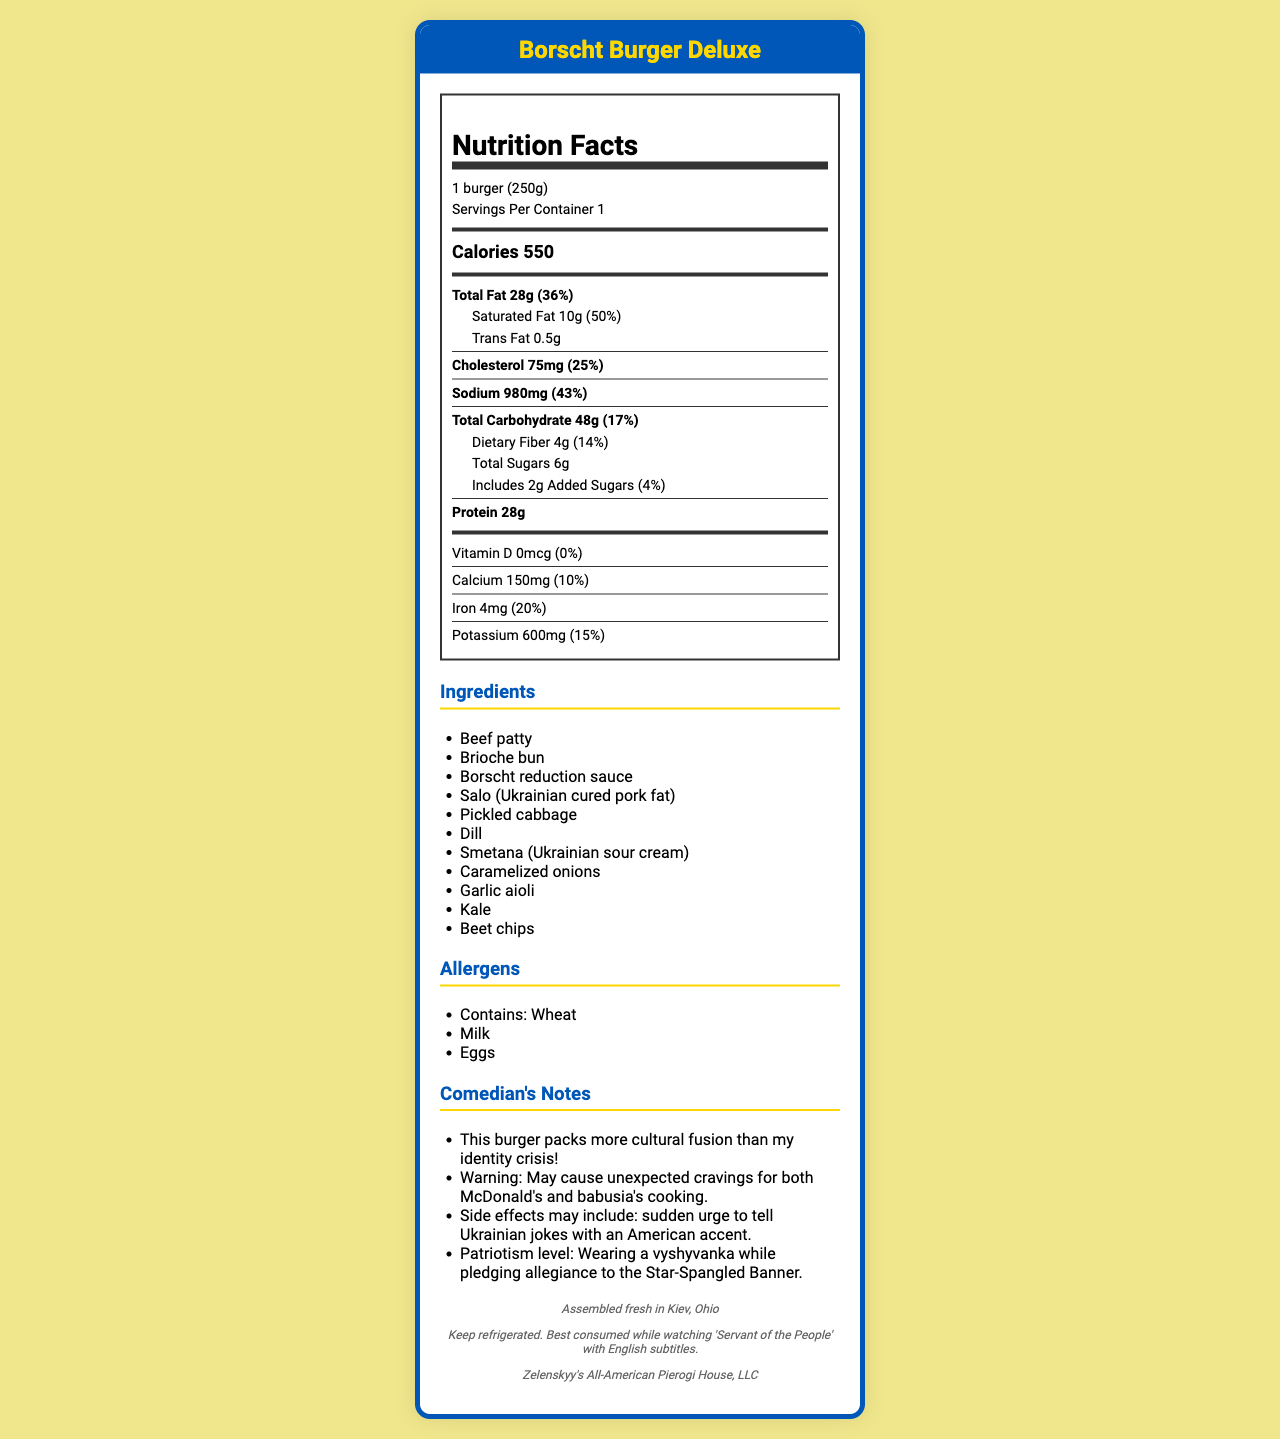what is the serving size of the Borscht Burger Deluxe? The serving size is explicitly mentioned as "1 burger (250g)" in the document.
Answer: 1 burger (250g) how many calories are there in one Borscht Burger Deluxe? The document states that one serving contains 550 calories.
Answer: 550 calories what is the amount of total fat in the Borscht Burger Deluxe? The document lists the total fat content as 28g.
Answer: 28g how much protein does one Borscht Burger Deluxe contain? The document specifies that one serving has 28g of protein.
Answer: 28g which ingredient is used as the sauce in the Borscht Burger Deluxe? Among the ingredients, the Borscht reduction sauce is listed for use in the burger.
Answer: Borscht reduction sauce which of these allergens does the Borscht Burger Deluxe contain? A. Peanuts B. Tree Nuts C. Milk D. Soy The allergens listed include Wheat, Milk, and Eggs. Milk is an option here.
Answer: C what is the preparation method for the Borscht Burger Deluxe? A. Assemble fresh in Kiev, Ohio B. Cook in New York, USA C. Served in Los Angeles, California The document mentions that the burger is "Assembled fresh in Kiev, Ohio."
Answer: A is there a significant amount of Vitamin D in the Borscht Burger Deluxe? The document states that the Vitamin D amount is 0mcg (0% Daily Value), indicating no significant amount.
Answer: No how much sodium is in one serving of the Borscht Burger Deluxe? The document specifies the sodium content as 980mg per serving.
Answer: 980mg what is the Salo used in the Borscht Burger Deluxe? The ingredient list includes Salo, which the document identifies as Ukrainian cured pork fat.
Answer: Ukrainian cured pork fat what side effects may consuming the Borscht Burger Deluxe cause? The comedian notes mention this as a potential side effect.
Answer: Sudden urge to tell Ukrainian jokes with an American accent describe the main idea of the document. The document gives an overview of nutritional facts, lists ingredients, highlights allergen information, and includes humorous notes that reflect the cultural fusion of the burger.
Answer: The document provides detailed nutritional information, ingredients, preparation method, and comedic notes for a product called the Borscht Burger Deluxe. This burger is a fusion dish combining American fast food elements with traditional Ukrainian ingredients, highlighting the comedian’s dual heritage. what is the exact quantity of added sugars in the Borscht Burger Deluxe? The document specifies that the burger has 2g of added sugars.
Answer: 2g what is the daily value percentage of iron in the Borscht Burger Deluxe? The document lists the daily value percentage of iron as 20%.
Answer: 20% how much potassium is found in one serving of the Borscht Burger Deluxe? The document indicates that one serving contains 600mg of potassium.
Answer: 600mg how many comedian notes are provided in the document? There are 4 comedian notes listed in the document.
Answer: 4 how should the Borscht Burger Deluxe be stored? The storage information specifies that the burger should be kept refrigerated and is best consumed while watching a particular show.
Answer: Keep refrigerated. Best consumed while watching 'Servant of the People' with English subtitles. what is the name of the manufacturer? The document states that the manufacturer is Zelenskyy's All-American Pierogi House, LLC.
Answer: Zelenskyy's All-American Pierogi House, LLC what is the daily value percentage for calcium in the Borscht Burger Deluxe? The document lists the daily value percentage for calcium as 10%.
Answer: 10% how much dietary fiber does one burger contain? The amount of dietary fiber per serving is given as 4g in the document.
Answer: 4g what is Smetana, one of the ingredients in the Borscht Burger Deluxe? The document mentions Smetana as an ingredient but does not provide a detailed description of what it is.
Answer: Not enough information 